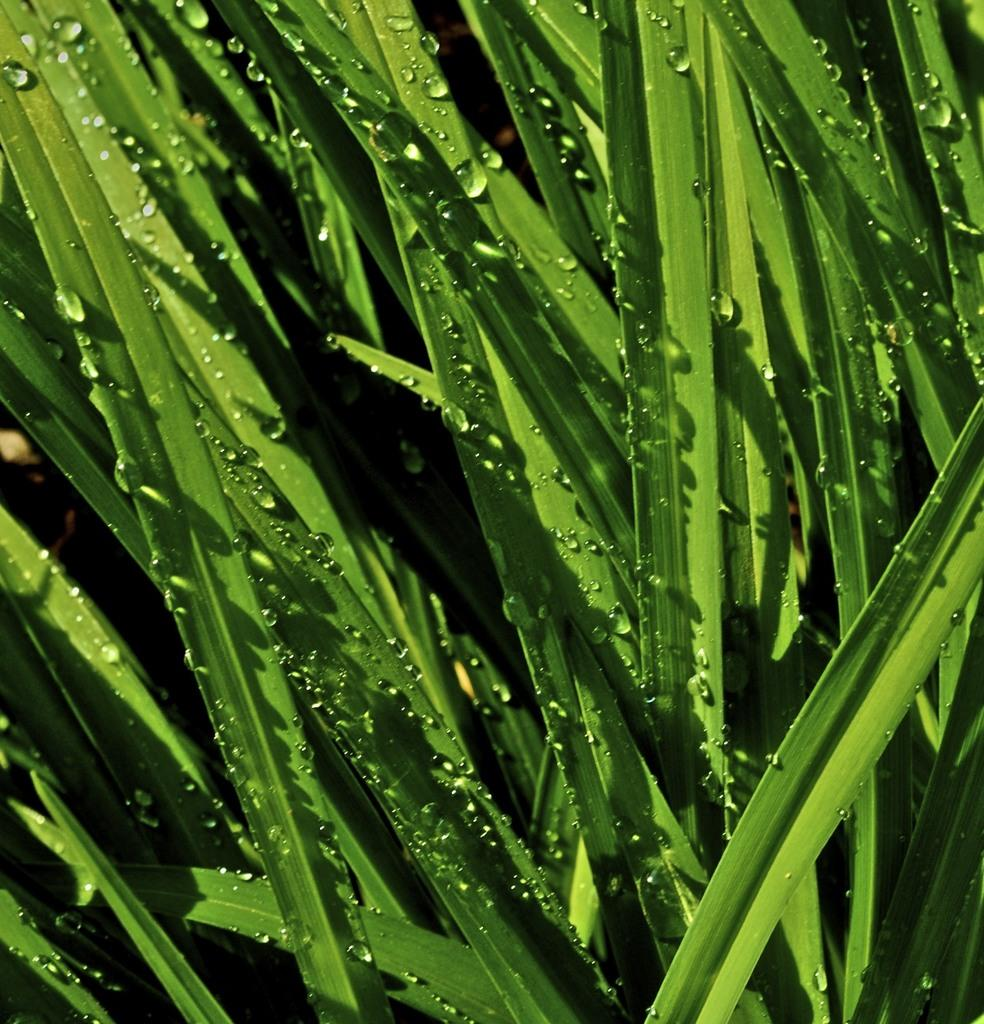What type of vegetation is present in the image? There are green color grass leaves in the image. Can you describe the condition of the grass leaves? The grass leaves have water droplets on them. Are there any cherries growing on the grass in the image? There is no mention of cherries in the image; it only features green color grass leaves with water droplets. Can you see any beds in the image? There is no mention of beds in the image; it only features green color grass leaves with water droplets. 